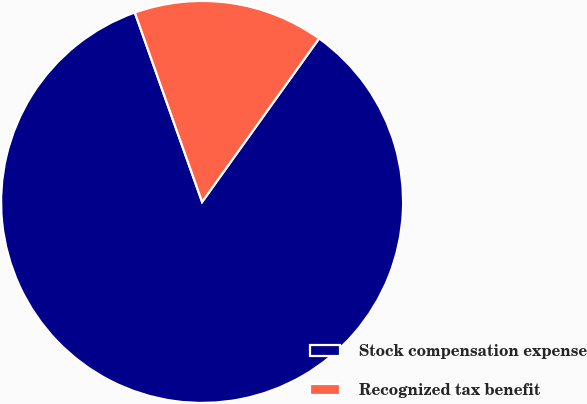<chart> <loc_0><loc_0><loc_500><loc_500><pie_chart><fcel>Stock compensation expense<fcel>Recognized tax benefit<nl><fcel>84.68%<fcel>15.32%<nl></chart> 